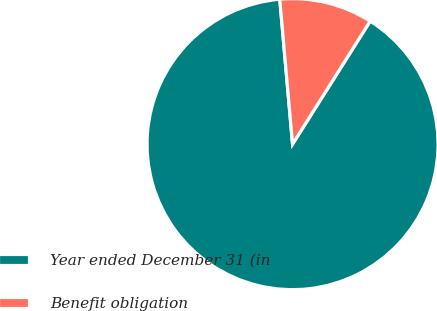Convert chart to OTSL. <chart><loc_0><loc_0><loc_500><loc_500><pie_chart><fcel>Year ended December 31 (in<fcel>Benefit obligation<nl><fcel>89.64%<fcel>10.36%<nl></chart> 